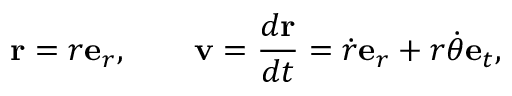Convert formula to latex. <formula><loc_0><loc_0><loc_500><loc_500>r = r e _ { r } , \quad v = { \frac { d r } { d t } } = { \dot { r } } e _ { r } + r { \dot { \theta } } e _ { t } ,</formula> 